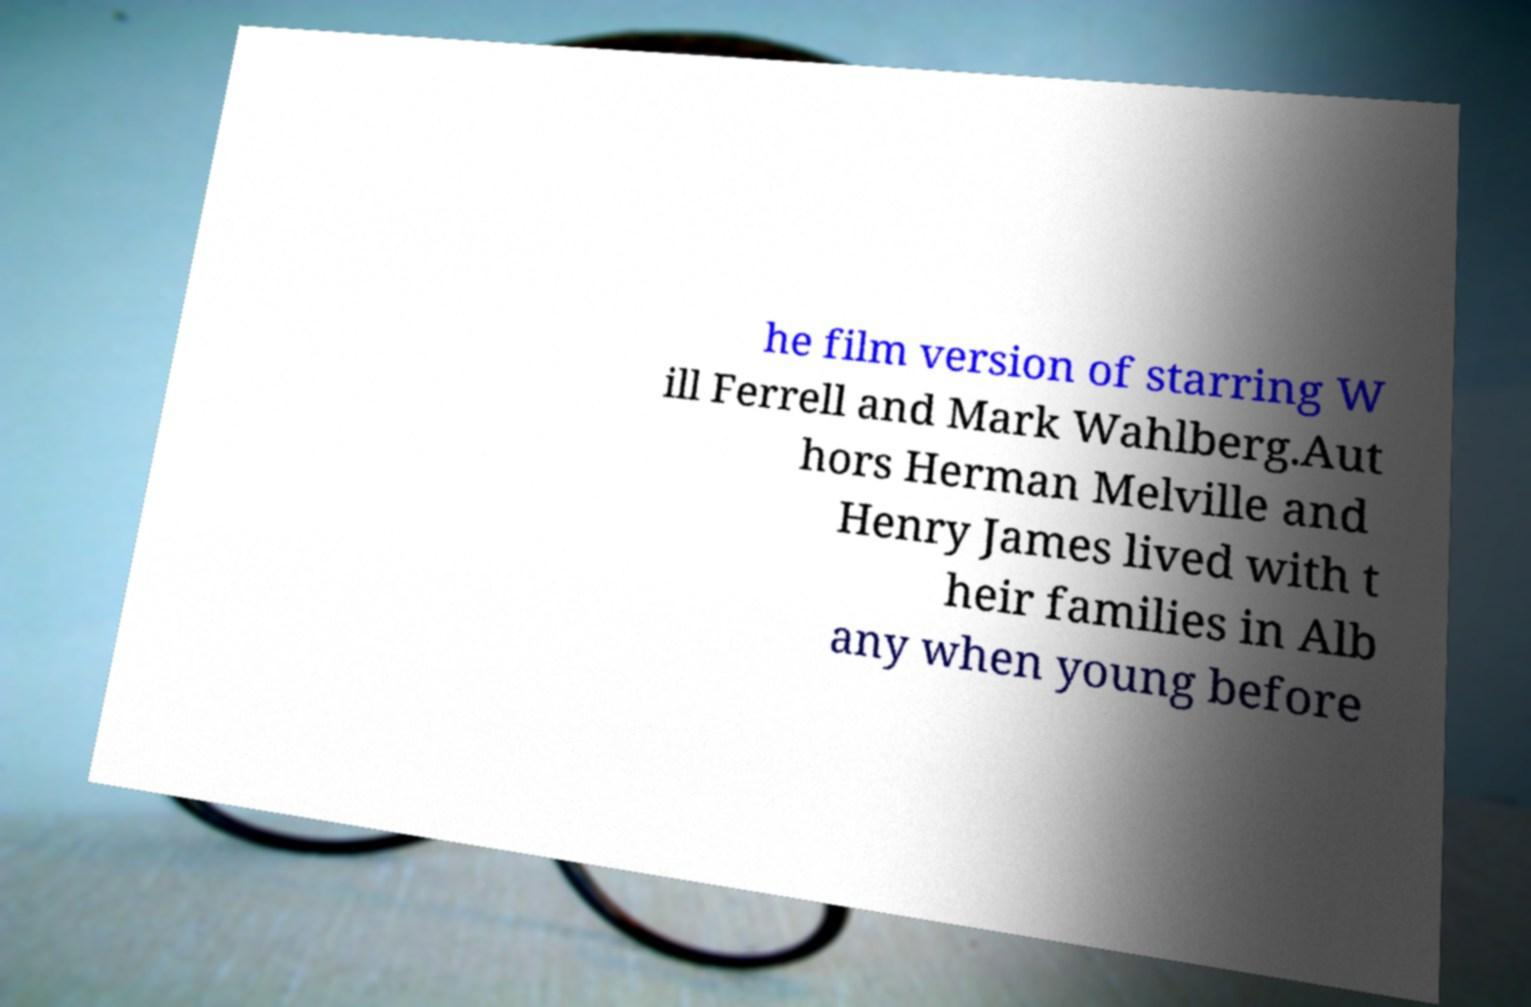Can you accurately transcribe the text from the provided image for me? he film version of starring W ill Ferrell and Mark Wahlberg.Aut hors Herman Melville and Henry James lived with t heir families in Alb any when young before 